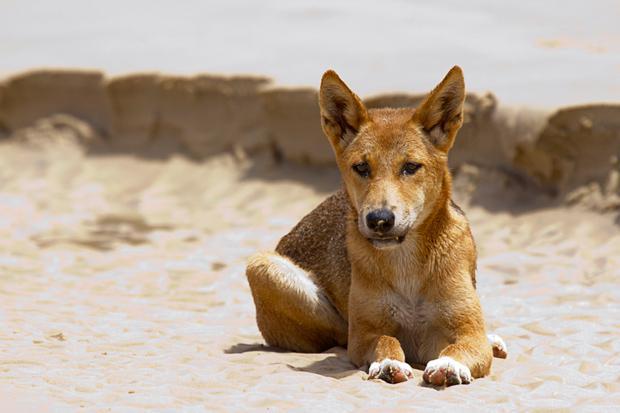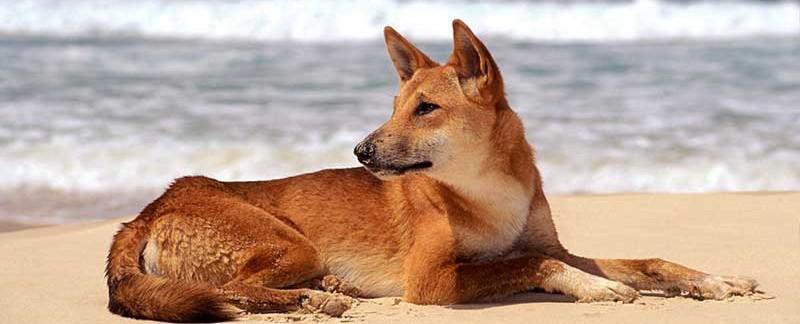The first image is the image on the left, the second image is the image on the right. Considering the images on both sides, is "At least one dog is in water, surrounded by water." valid? Answer yes or no. No. 